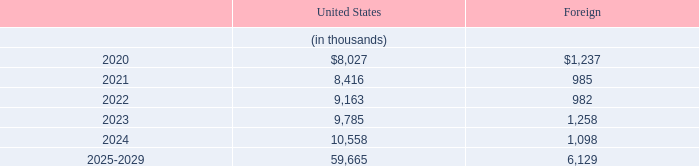Expected Future Pension Benefit Payments
Future benefit payments are expected to be paid as follows:
What is the Expected Future Pension Benefit Payments in 2020 under United States?
Answer scale should be: thousand. $8,027. In which regions would future benefit payments be expected to be paid? United states, foreign. What is the payment for  2025-2029 for Foreign?
Answer scale should be: thousand. 6,129. What is the difference in payment for United States and Foreign for 2020?
Answer scale should be: thousand. 8,027-1,237
Answer: 6790. What would the change in Expected Future Pension Benefit Payments under the United States in 2022 from 2021 be?
Answer scale should be: thousand. 9,163-8,416
Answer: 747. What would the percentage change in Expected Future Pension Benefit Payments under the United States in 2022 from 2021 be?
Answer scale should be: percent. (9,163-8,416)/8,416
Answer: 8.88. 